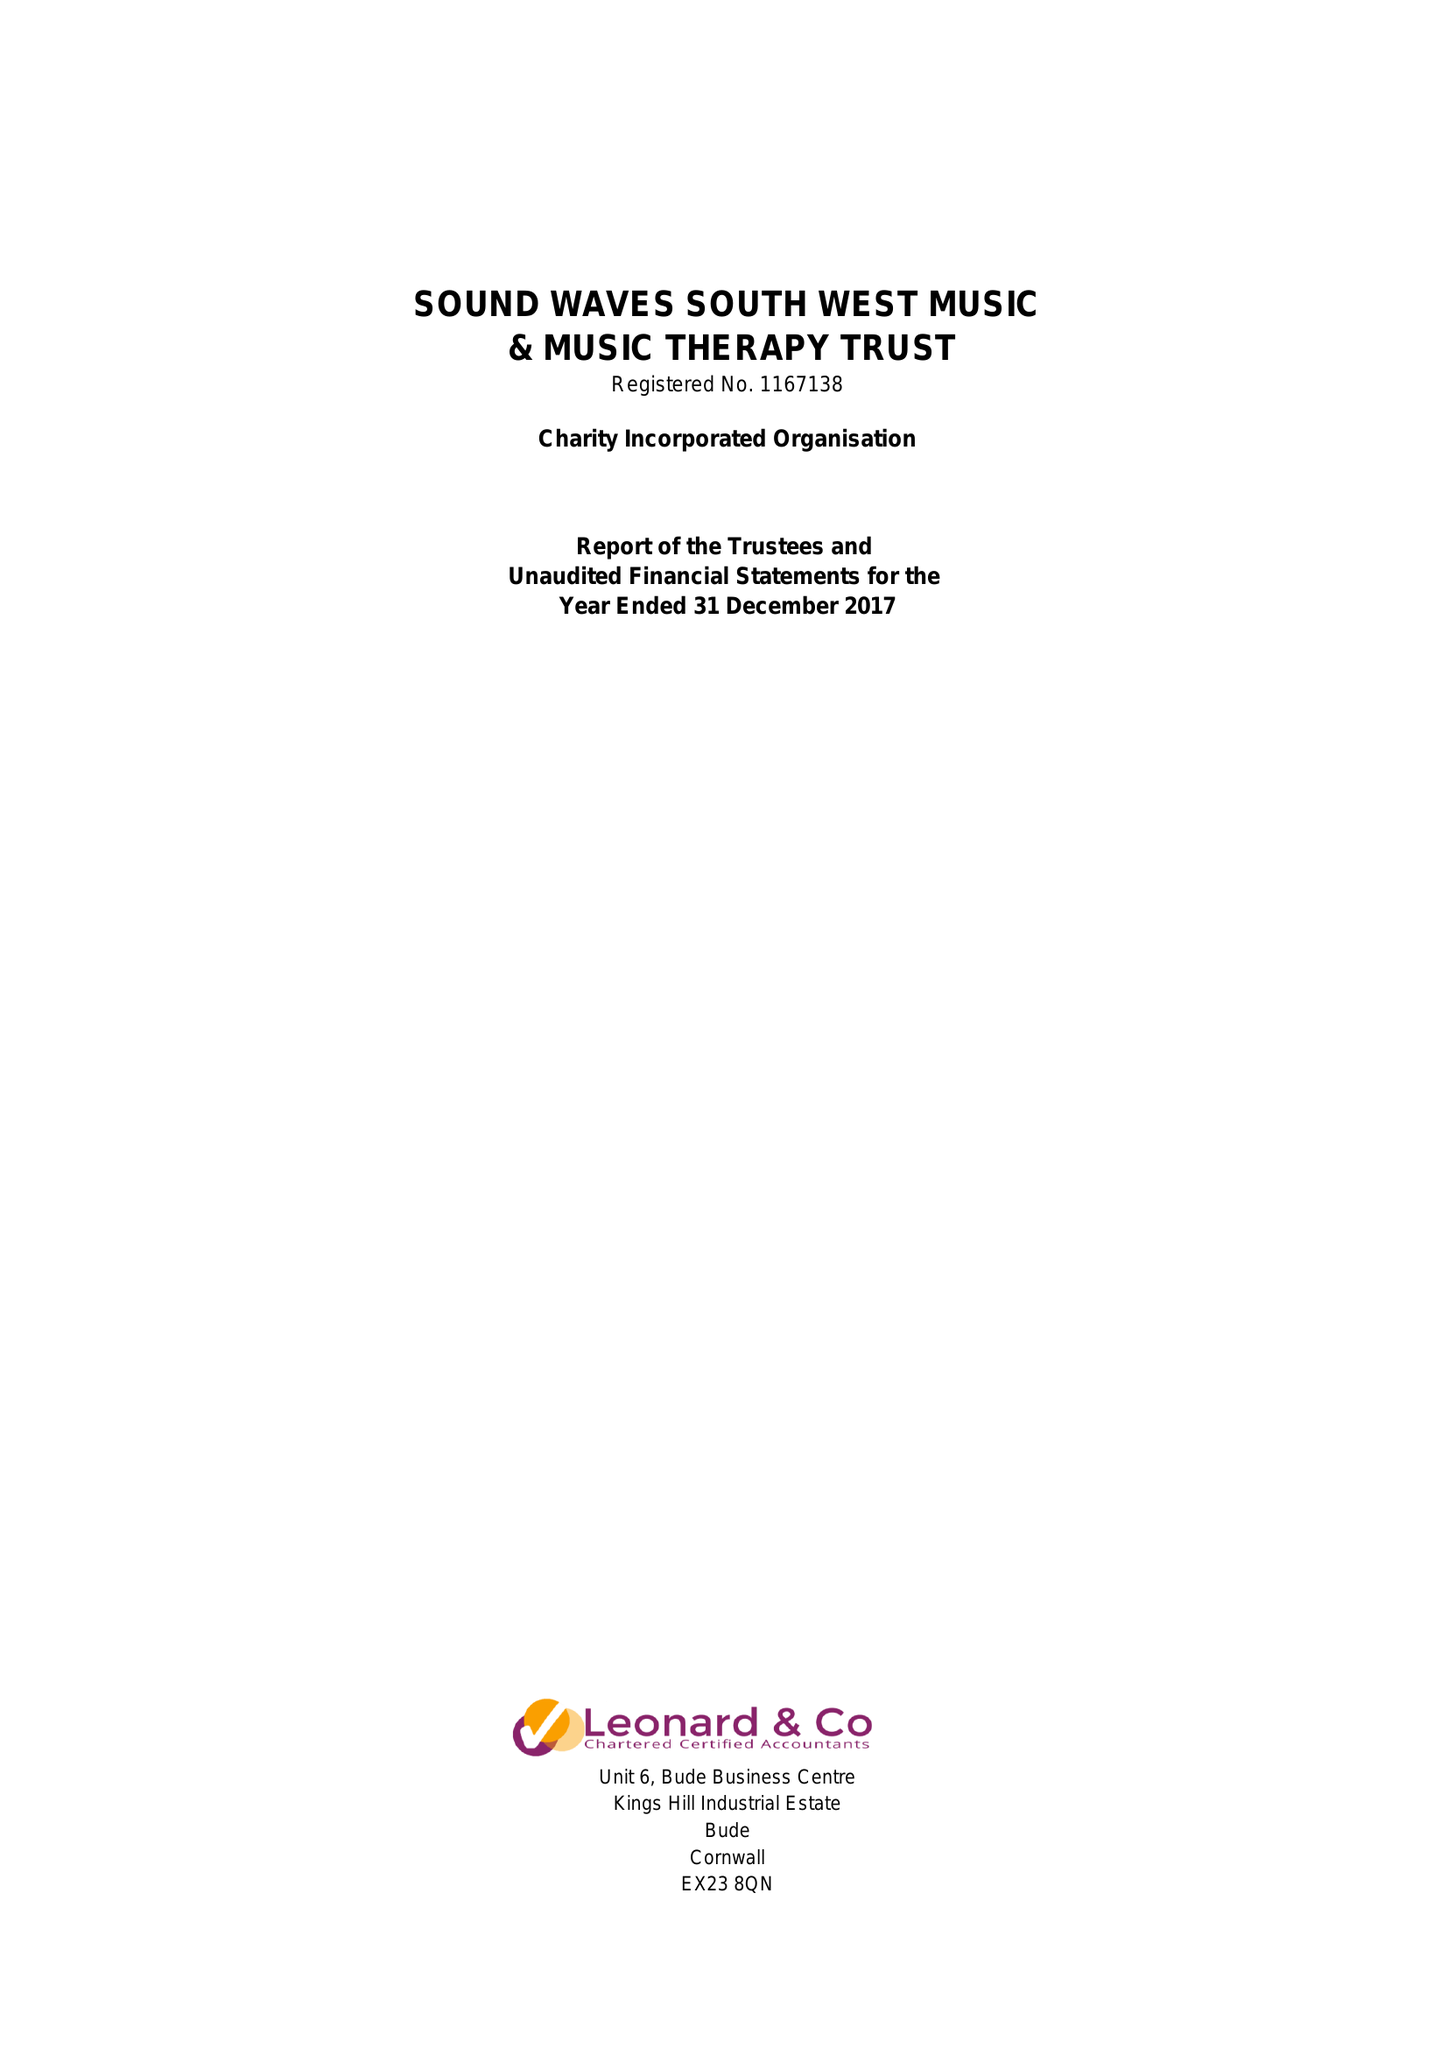What is the value for the charity_number?
Answer the question using a single word or phrase. 1167138 